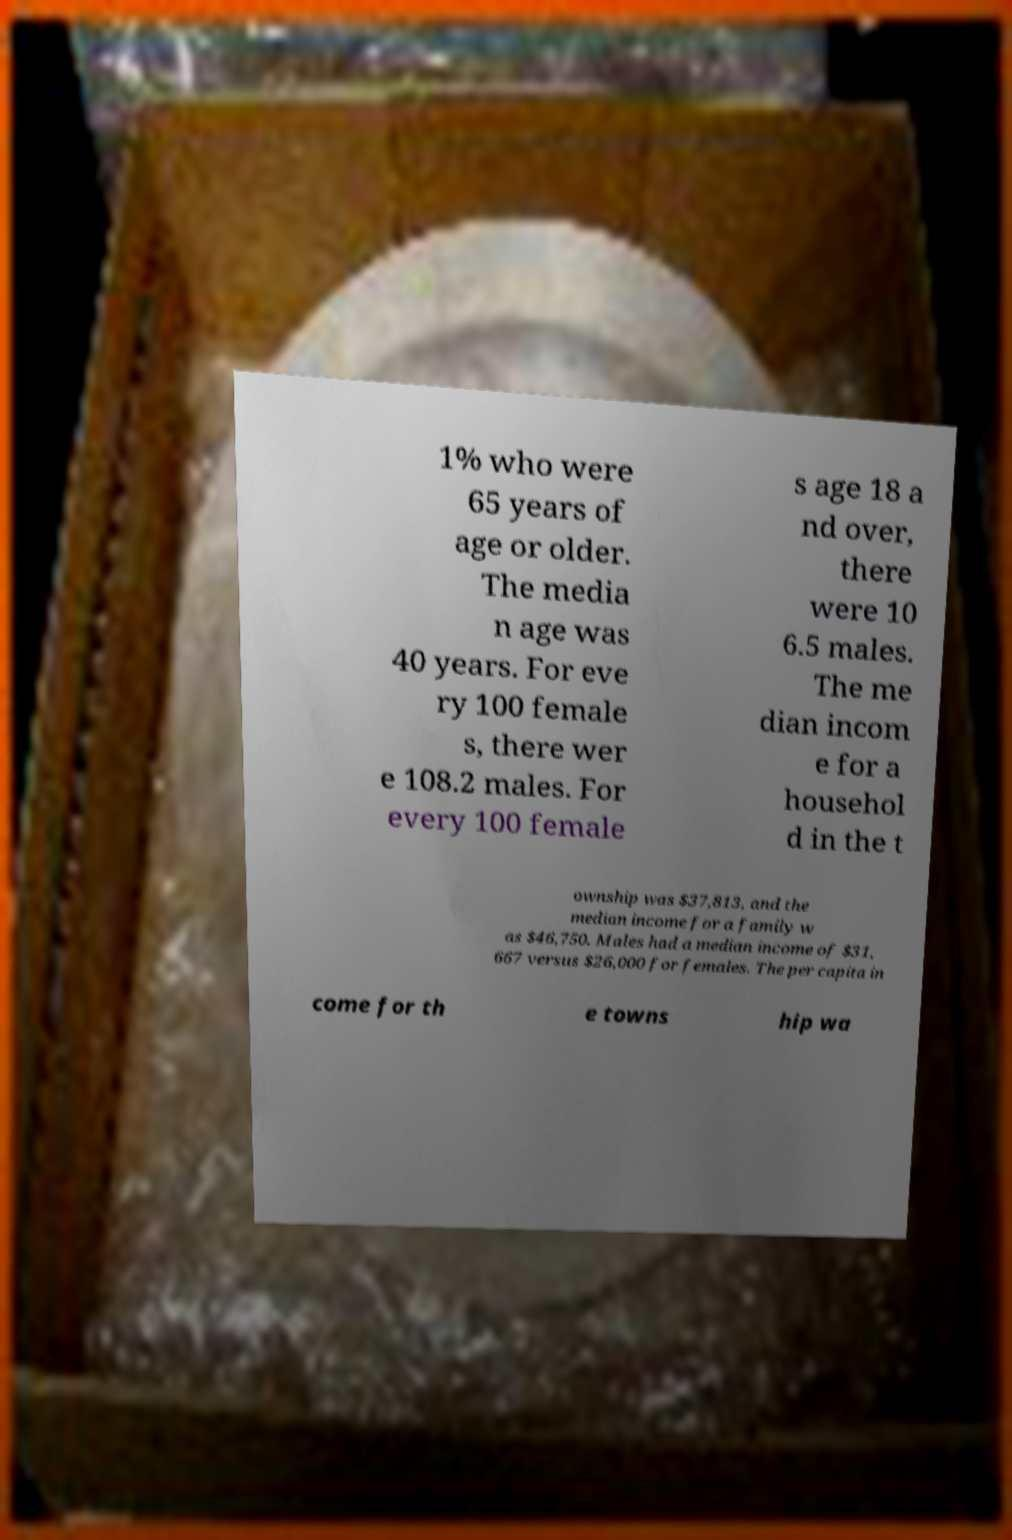Please read and relay the text visible in this image. What does it say? 1% who were 65 years of age or older. The media n age was 40 years. For eve ry 100 female s, there wer e 108.2 males. For every 100 female s age 18 a nd over, there were 10 6.5 males. The me dian incom e for a househol d in the t ownship was $37,813, and the median income for a family w as $46,750. Males had a median income of $31, 667 versus $26,000 for females. The per capita in come for th e towns hip wa 